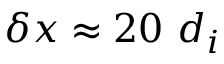<formula> <loc_0><loc_0><loc_500><loc_500>\delta x \approx 2 0 d _ { i }</formula> 